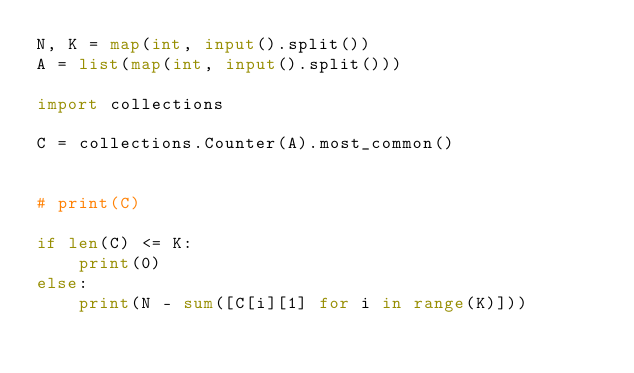<code> <loc_0><loc_0><loc_500><loc_500><_Python_>N, K = map(int, input().split())
A = list(map(int, input().split()))

import collections

C = collections.Counter(A).most_common()


# print(C)

if len(C) <= K:
    print(0)
else:
    print(N - sum([C[i][1] for i in range(K)]))</code> 